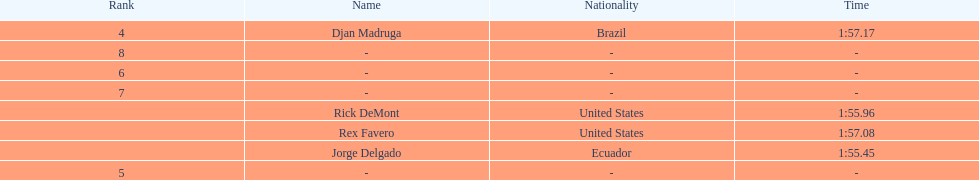What come after rex f. Djan Madruga. 